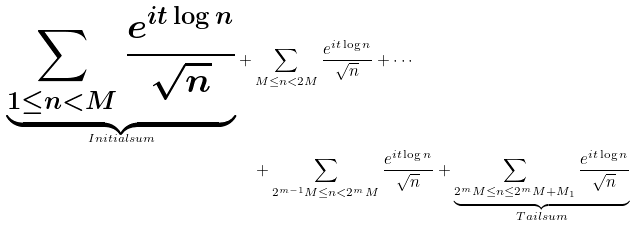<formula> <loc_0><loc_0><loc_500><loc_500>\underbrace { \sum _ { 1 \leq n < M } \frac { e ^ { i t \log n } } { \sqrt { n } } } _ { I n i t i a l s u m } + & \sum _ { M \leq n < 2 M } \frac { e ^ { i t \log n } } { \sqrt { n } } + \cdots \\ & + \sum _ { 2 ^ { m - 1 } M \leq n < 2 ^ { m } M } \frac { e ^ { i t \log n } } { \sqrt { n } } + \underbrace { \sum _ { 2 ^ { m } M \leq n \leq 2 ^ { m } M + M _ { 1 } } \frac { e ^ { i t \log n } } { \sqrt { n } } } _ { T a i l s u m }</formula> 